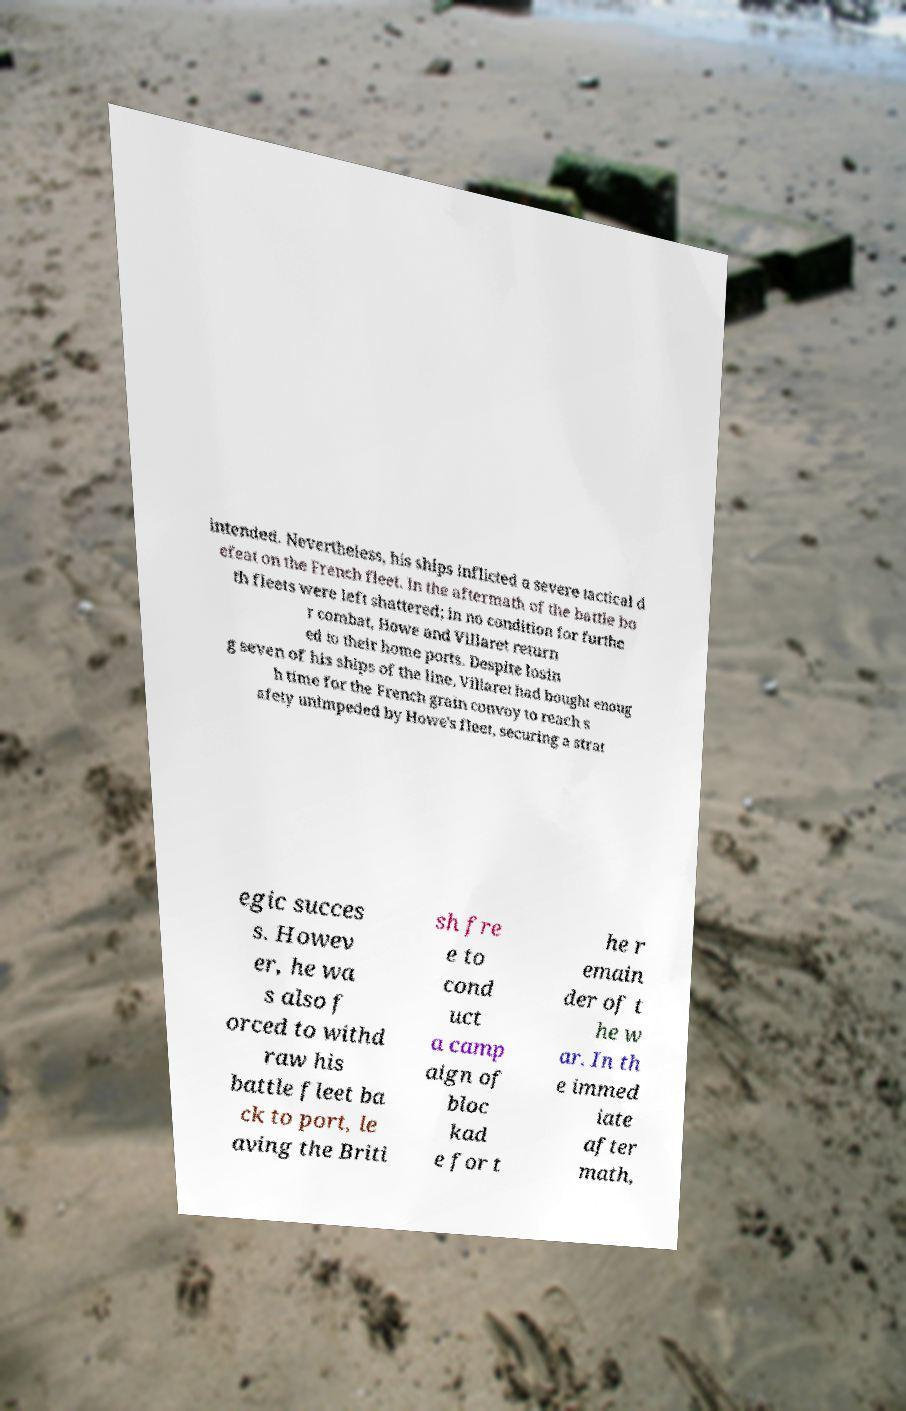Please identify and transcribe the text found in this image. intended. Nevertheless, his ships inflicted a severe tactical d efeat on the French fleet. In the aftermath of the battle bo th fleets were left shattered; in no condition for furthe r combat, Howe and Villaret return ed to their home ports. Despite losin g seven of his ships of the line, Villaret had bought enoug h time for the French grain convoy to reach s afety unimpeded by Howe's fleet, securing a strat egic succes s. Howev er, he wa s also f orced to withd raw his battle fleet ba ck to port, le aving the Briti sh fre e to cond uct a camp aign of bloc kad e for t he r emain der of t he w ar. In th e immed iate after math, 